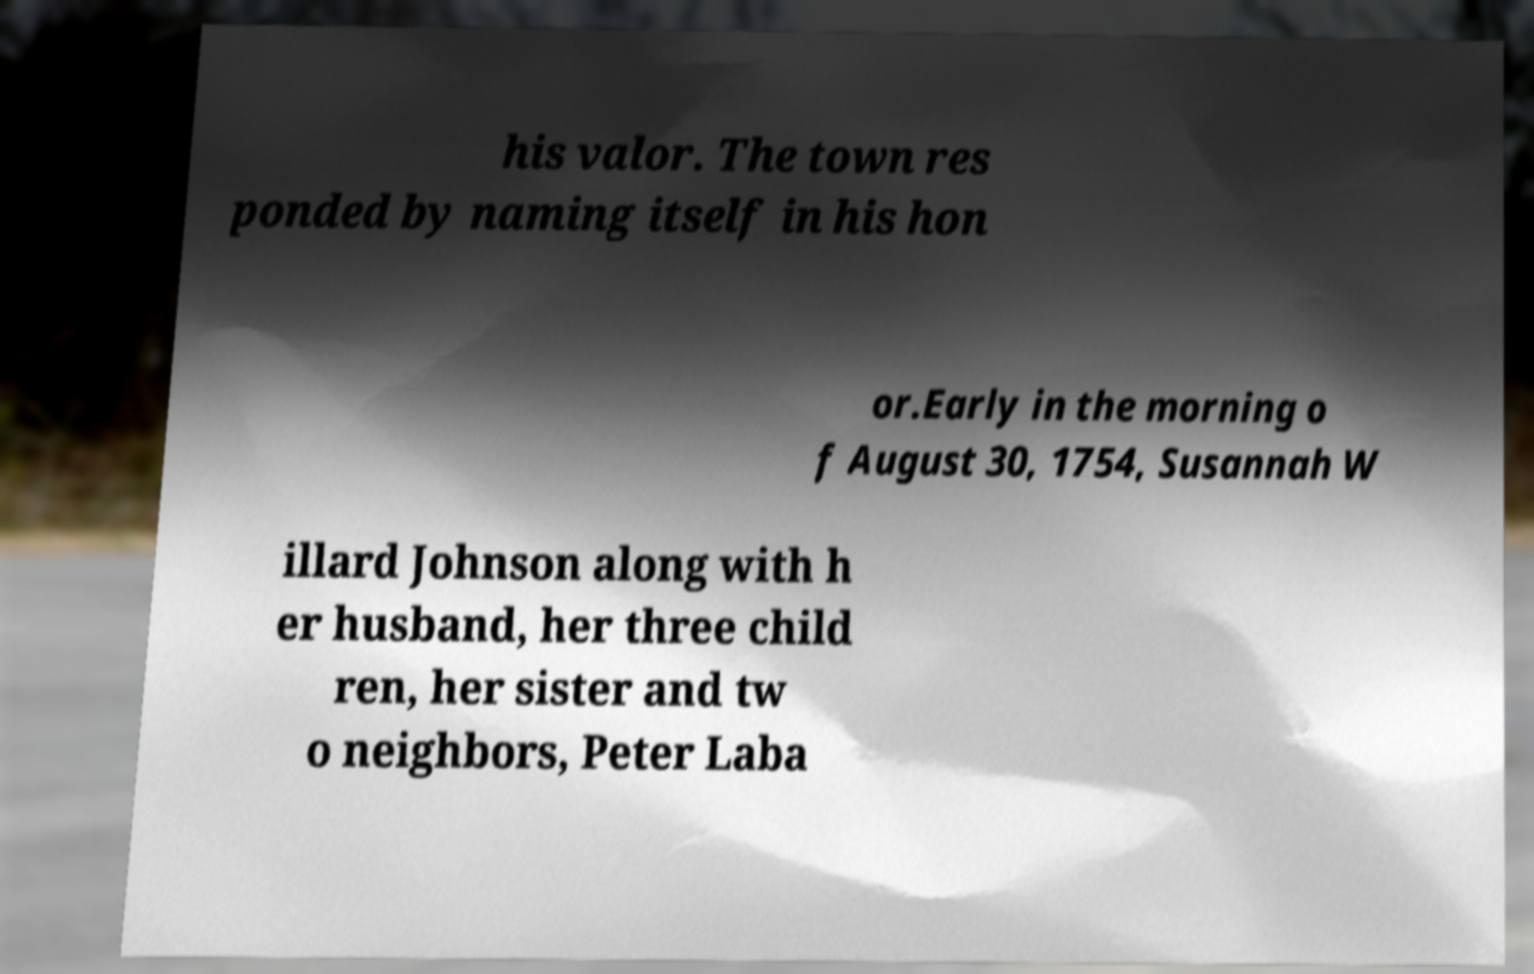Please identify and transcribe the text found in this image. his valor. The town res ponded by naming itself in his hon or.Early in the morning o f August 30, 1754, Susannah W illard Johnson along with h er husband, her three child ren, her sister and tw o neighbors, Peter Laba 